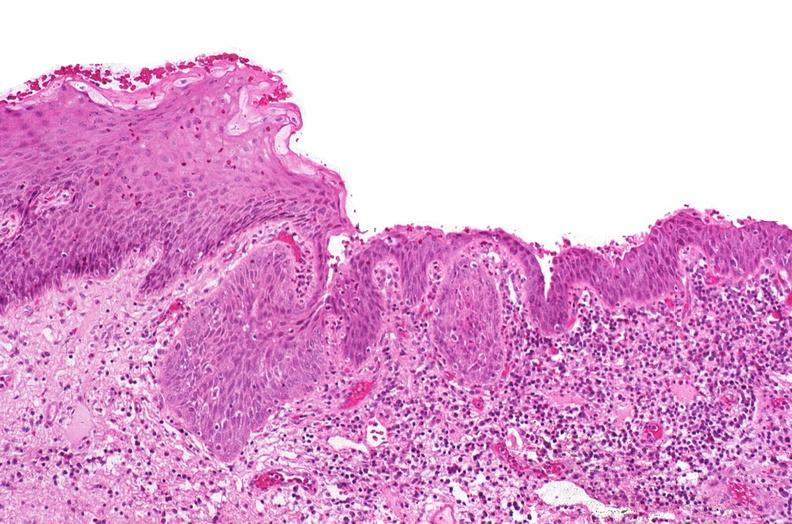s this image shows of smooth muscle cell with lipid in sarcoplasm and lipid present?
Answer the question using a single word or phrase. No 